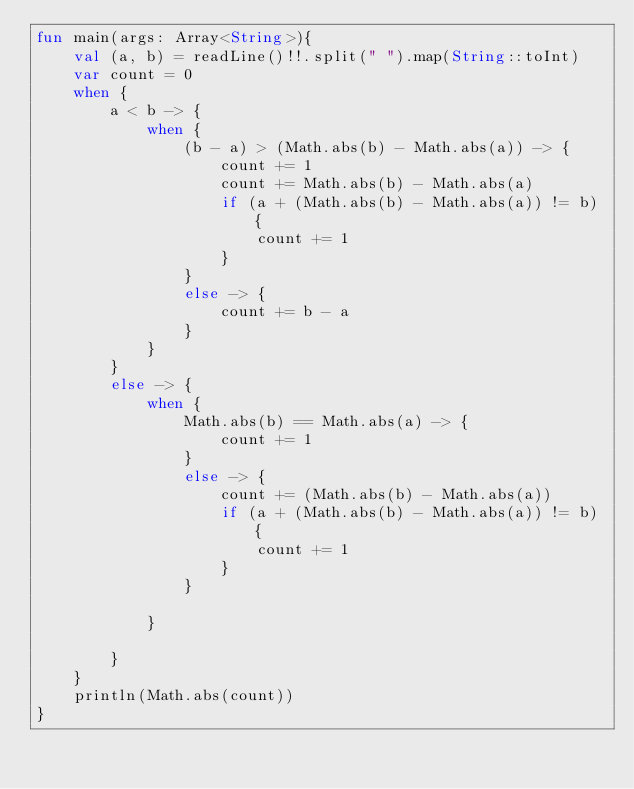Convert code to text. <code><loc_0><loc_0><loc_500><loc_500><_Kotlin_>fun main(args: Array<String>){
    val (a, b) = readLine()!!.split(" ").map(String::toInt)
    var count = 0
    when {
        a < b -> {
            when {
                (b - a) > (Math.abs(b) - Math.abs(a)) -> {
                    count += 1
                    count += Math.abs(b) - Math.abs(a)
                    if (a + (Math.abs(b) - Math.abs(a)) != b) {
                        count += 1
                    }
                }
                else -> {
                    count += b - a
                }
            }
        }
        else -> {
            when {
                Math.abs(b) == Math.abs(a) -> {
                    count += 1
                }
                else -> {
                    count += (Math.abs(b) - Math.abs(a))
                    if (a + (Math.abs(b) - Math.abs(a)) != b) {
                        count += 1
                    }
                }
            
            }
            
        }
    }
    println(Math.abs(count))
}</code> 